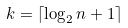<formula> <loc_0><loc_0><loc_500><loc_500>k = \lceil \log _ { 2 } n + 1 \rceil</formula> 